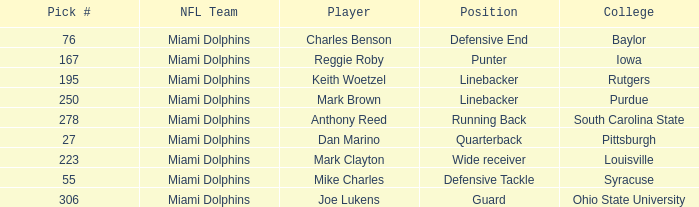If the Position is Running Back what is the Total number of Pick #? 1.0. 